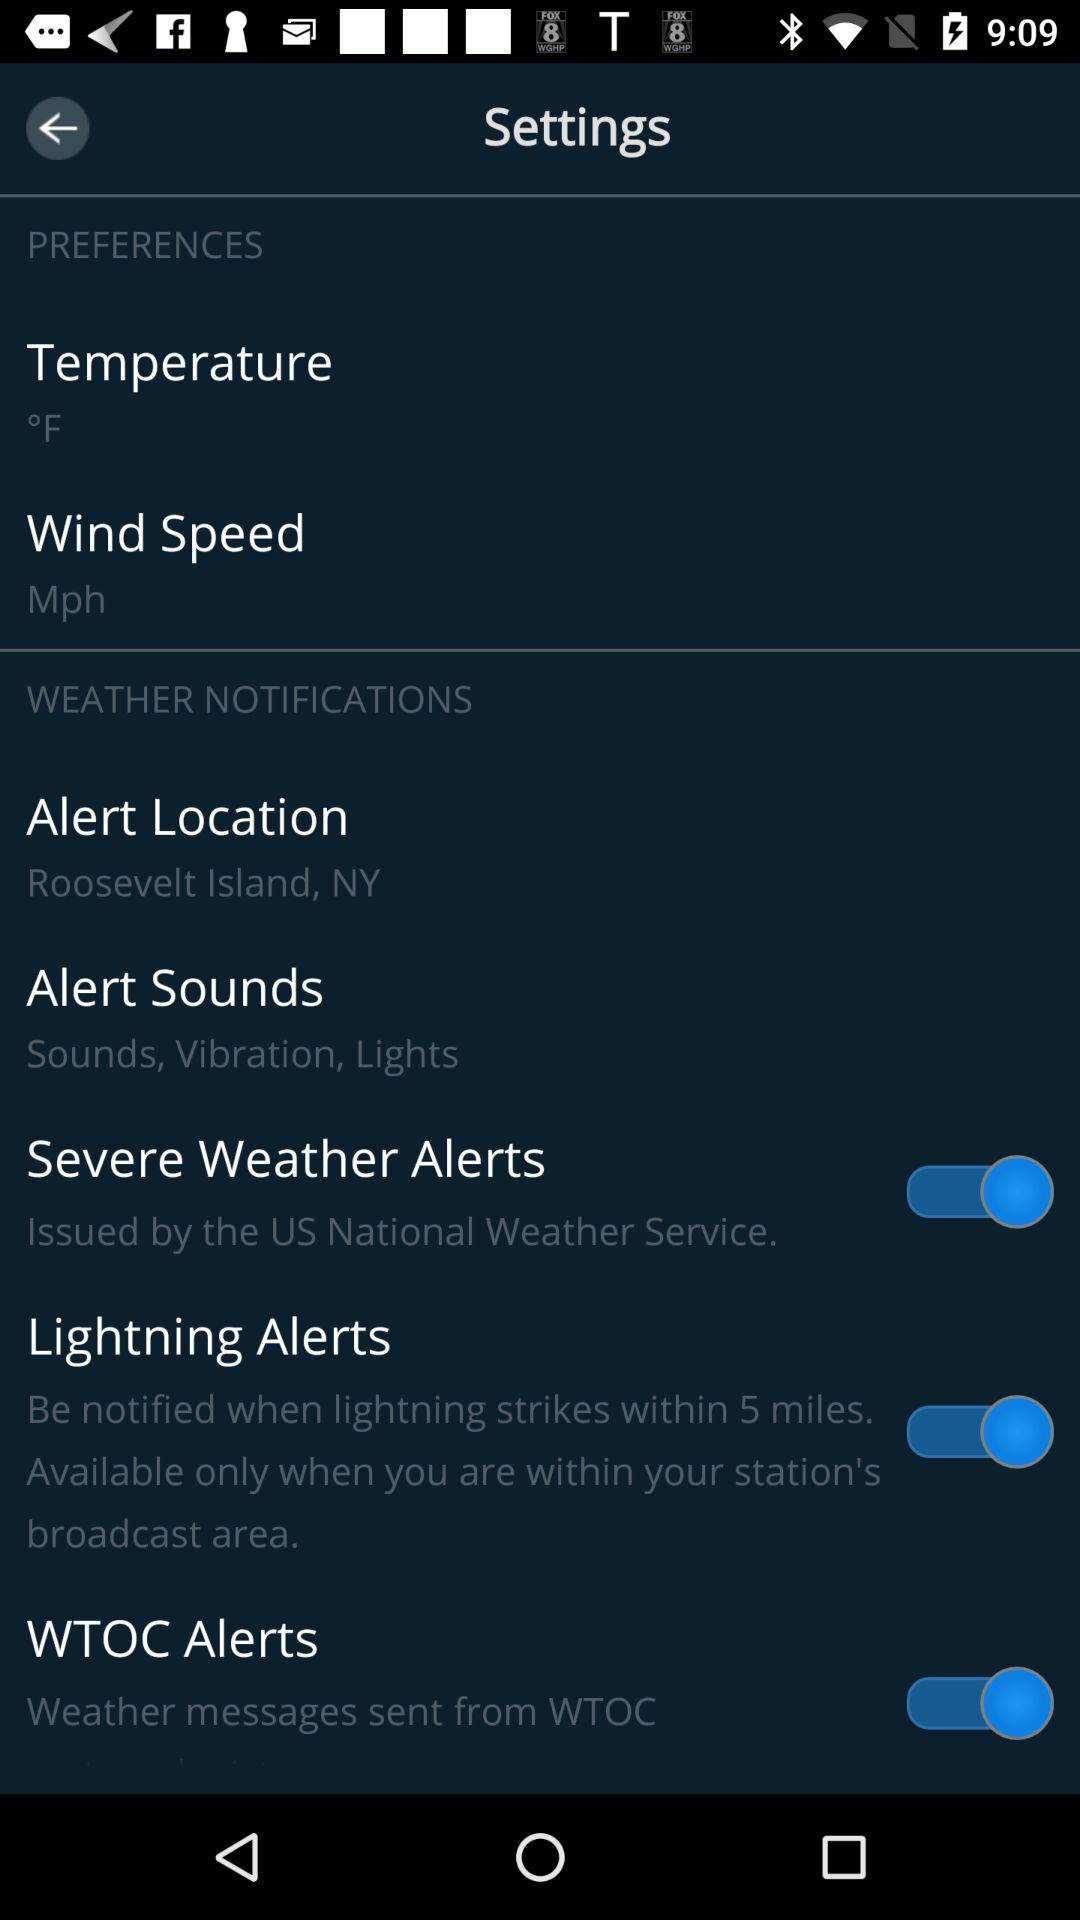Is "WEATHER NOTIFICATIONS" selected or not selected?
When the provided information is insufficient, respond with <no answer>. <no answer> 